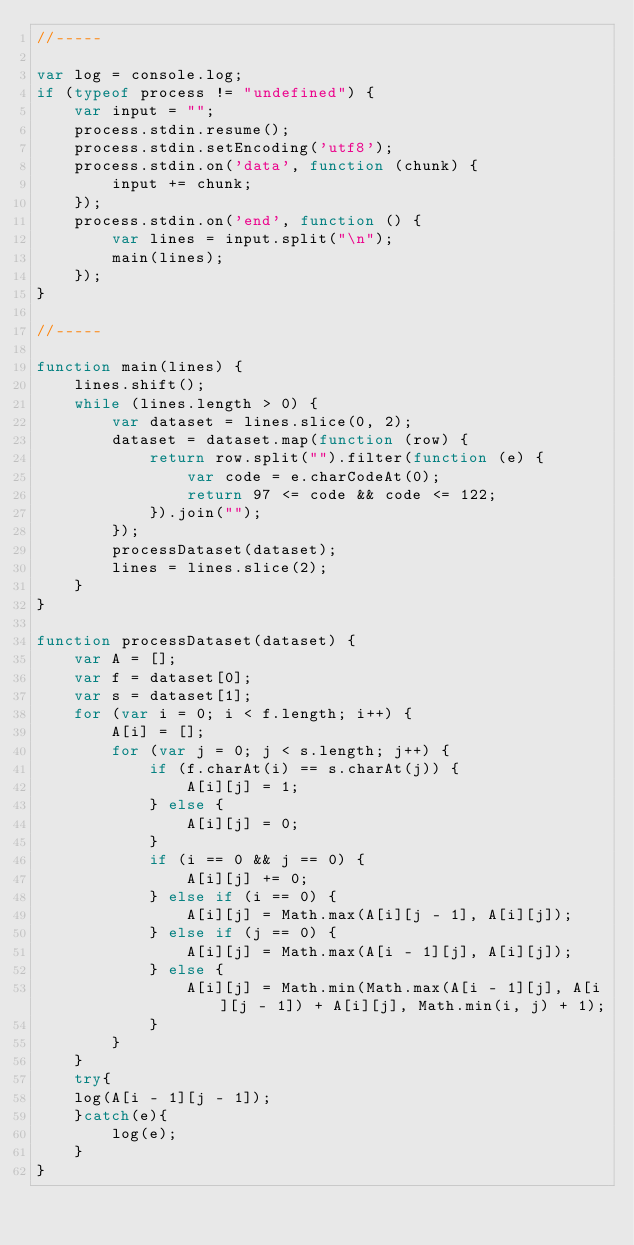Convert code to text. <code><loc_0><loc_0><loc_500><loc_500><_JavaScript_>//-----

var log = console.log;
if (typeof process != "undefined") {
	var input = "";
	process.stdin.resume();
	process.stdin.setEncoding('utf8');
	process.stdin.on('data', function (chunk) {
		input += chunk;
	});
	process.stdin.on('end', function () {
		var lines = input.split("\n");
		main(lines);
	});
}

//-----

function main(lines) {
	lines.shift();
	while (lines.length > 0) {
		var dataset = lines.slice(0, 2);
		dataset = dataset.map(function (row) {
			return row.split("").filter(function (e) {
				var code = e.charCodeAt(0);
				return 97 <= code && code <= 122;
			}).join("");
		});
		processDataset(dataset);
		lines = lines.slice(2);
	}
}

function processDataset(dataset) {
	var A = [];
	var f = dataset[0];
	var s = dataset[1];
	for (var i = 0; i < f.length; i++) {
		A[i] = [];
		for (var j = 0; j < s.length; j++) {
			if (f.charAt(i) == s.charAt(j)) {
				A[i][j] = 1;
			} else {
				A[i][j] = 0;
			}
			if (i == 0 && j == 0) {
				A[i][j] += 0;
			} else if (i == 0) {
				A[i][j] = Math.max(A[i][j - 1], A[i][j]);
			} else if (j == 0) {
				A[i][j] = Math.max(A[i - 1][j], A[i][j]);
			} else {
				A[i][j] = Math.min(Math.max(A[i - 1][j], A[i][j - 1]) + A[i][j], Math.min(i, j) + 1);
			}
		}
	}
	try{
	log(A[i - 1][j - 1]);
	}catch(e){
		log(e);
	}
}</code> 